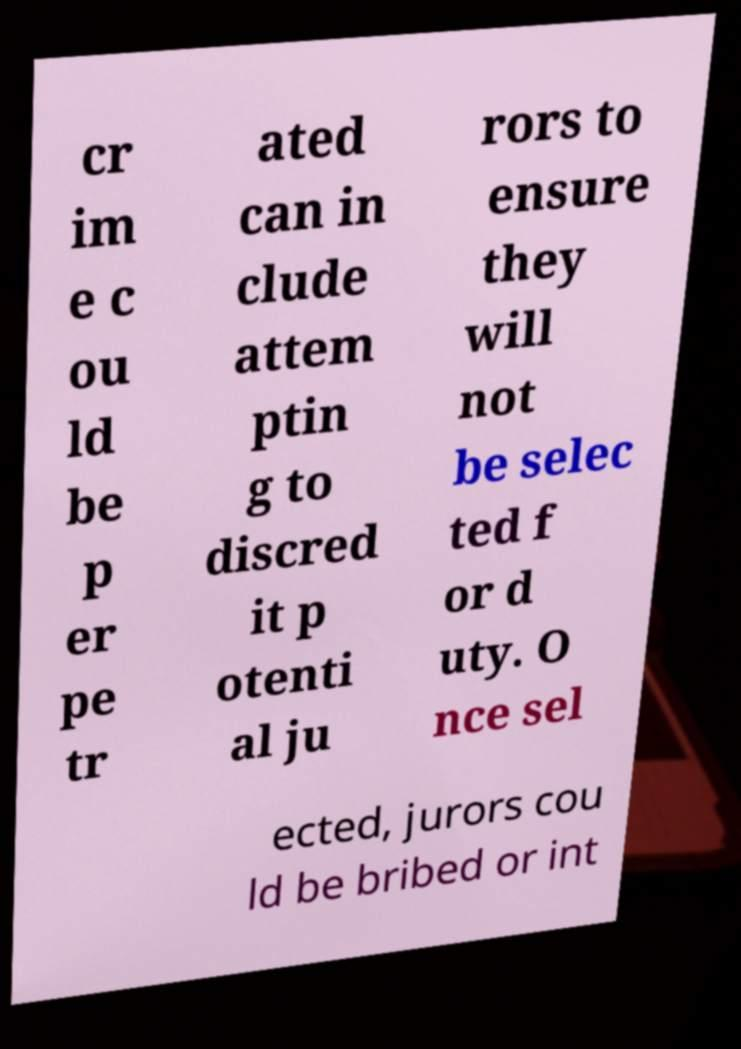Please identify and transcribe the text found in this image. cr im e c ou ld be p er pe tr ated can in clude attem ptin g to discred it p otenti al ju rors to ensure they will not be selec ted f or d uty. O nce sel ected, jurors cou ld be bribed or int 